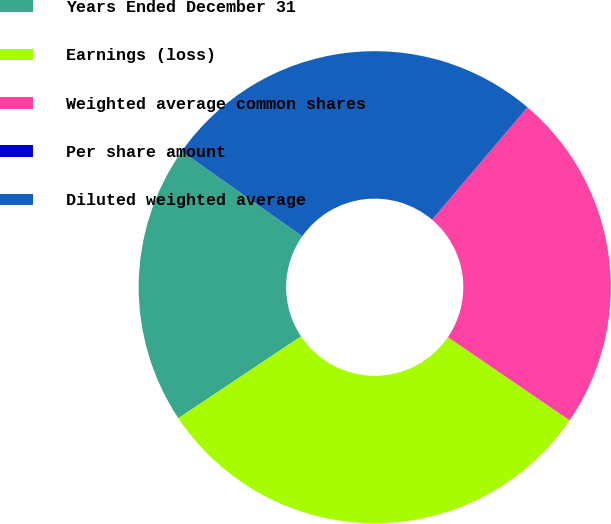Convert chart. <chart><loc_0><loc_0><loc_500><loc_500><pie_chart><fcel>Years Ended December 31<fcel>Earnings (loss)<fcel>Weighted average common shares<fcel>Per share amount<fcel>Diluted weighted average<nl><fcel>19.13%<fcel>31.1%<fcel>23.33%<fcel>0.01%<fcel>26.44%<nl></chart> 